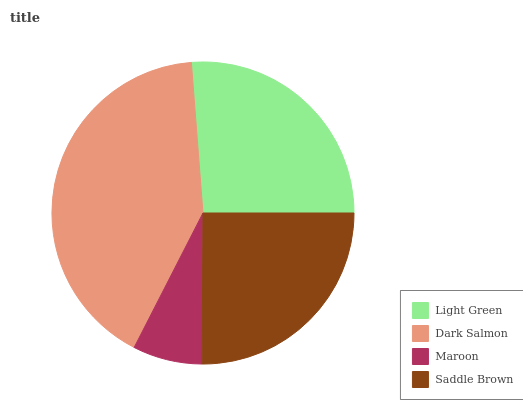Is Maroon the minimum?
Answer yes or no. Yes. Is Dark Salmon the maximum?
Answer yes or no. Yes. Is Dark Salmon the minimum?
Answer yes or no. No. Is Maroon the maximum?
Answer yes or no. No. Is Dark Salmon greater than Maroon?
Answer yes or no. Yes. Is Maroon less than Dark Salmon?
Answer yes or no. Yes. Is Maroon greater than Dark Salmon?
Answer yes or no. No. Is Dark Salmon less than Maroon?
Answer yes or no. No. Is Light Green the high median?
Answer yes or no. Yes. Is Saddle Brown the low median?
Answer yes or no. Yes. Is Maroon the high median?
Answer yes or no. No. Is Dark Salmon the low median?
Answer yes or no. No. 